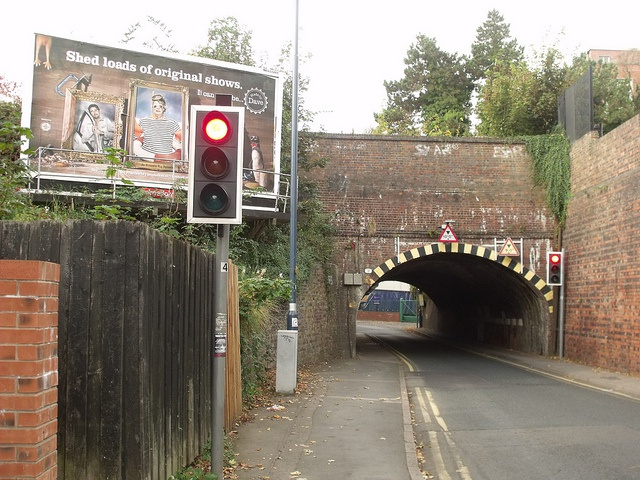Describe the objects in this image and their specific colors. I can see traffic light in white, gray, black, and maroon tones and traffic light in white, ivory, black, gray, and maroon tones in this image. 